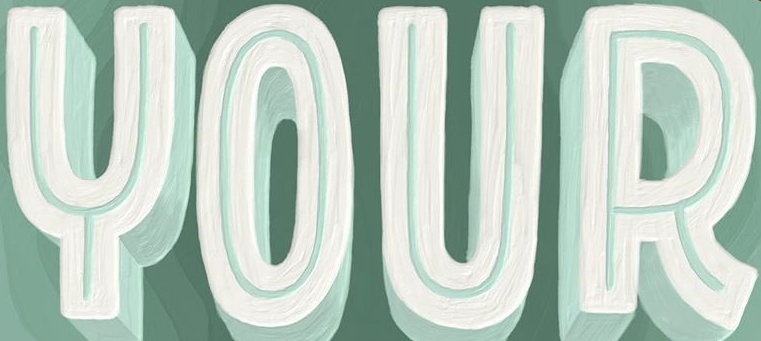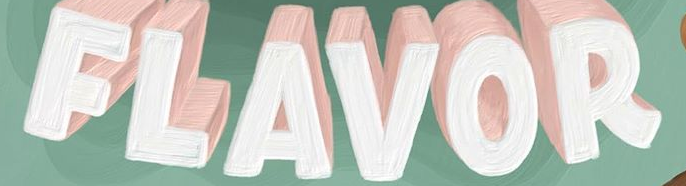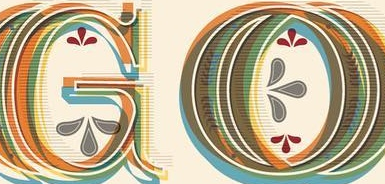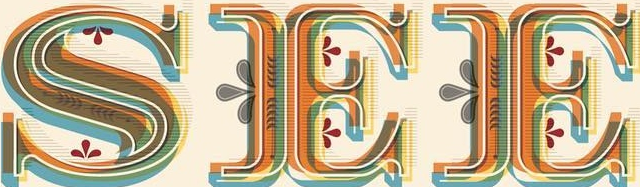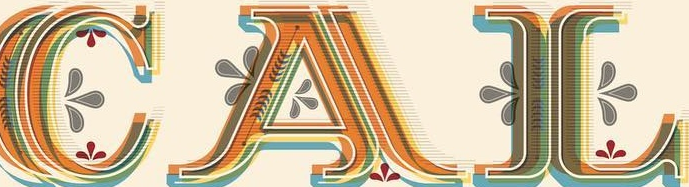What words are shown in these images in order, separated by a semicolon? YOUR; FLAVOR; GO; SEE; CAL 